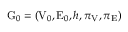<formula> <loc_0><loc_0><loc_500><loc_500>G _ { 0 } = \left ( V _ { 0 } , E _ { 0 } , h , \pi _ { V } , \pi _ { E } \right )</formula> 